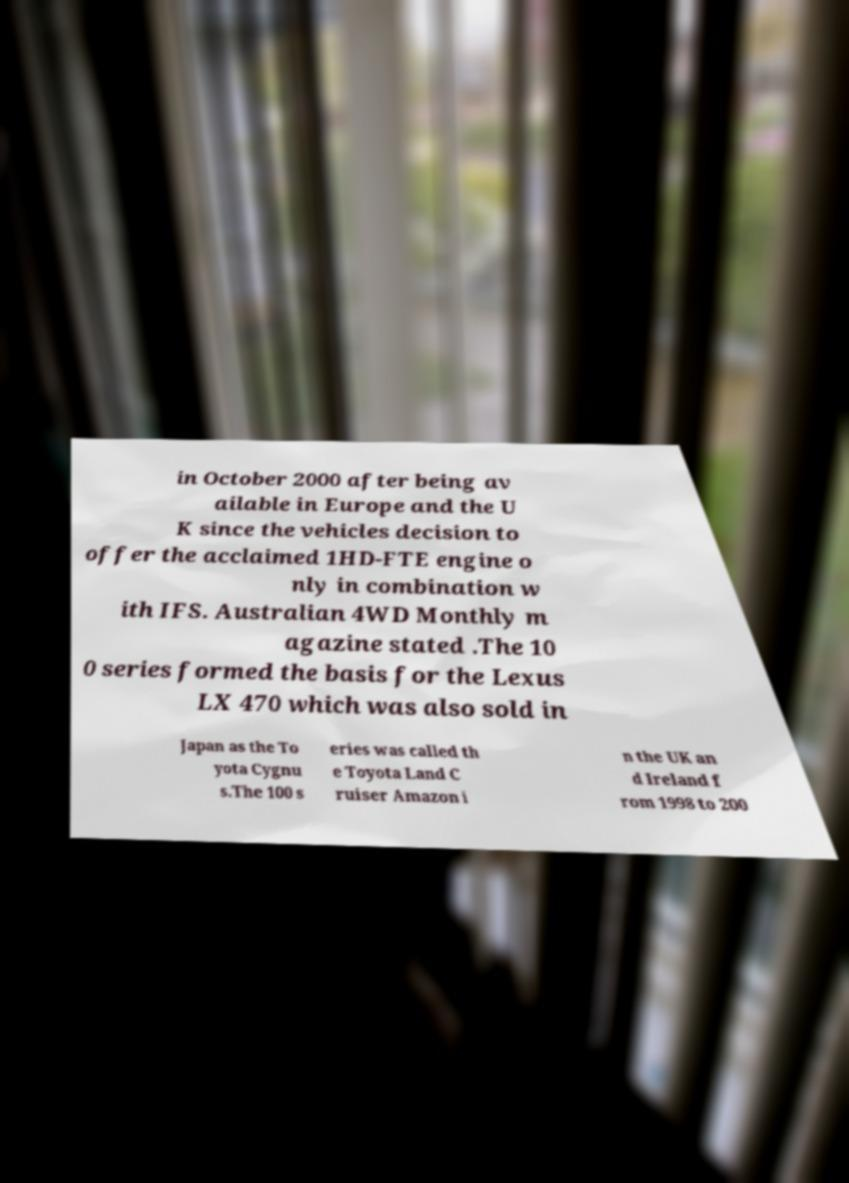Could you extract and type out the text from this image? in October 2000 after being av ailable in Europe and the U K since the vehicles decision to offer the acclaimed 1HD-FTE engine o nly in combination w ith IFS. Australian 4WD Monthly m agazine stated .The 10 0 series formed the basis for the Lexus LX 470 which was also sold in Japan as the To yota Cygnu s.The 100 s eries was called th e Toyota Land C ruiser Amazon i n the UK an d Ireland f rom 1998 to 200 